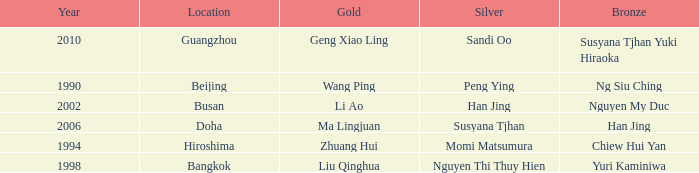What's the lowest Year with the Location of Bangkok? 1998.0. 